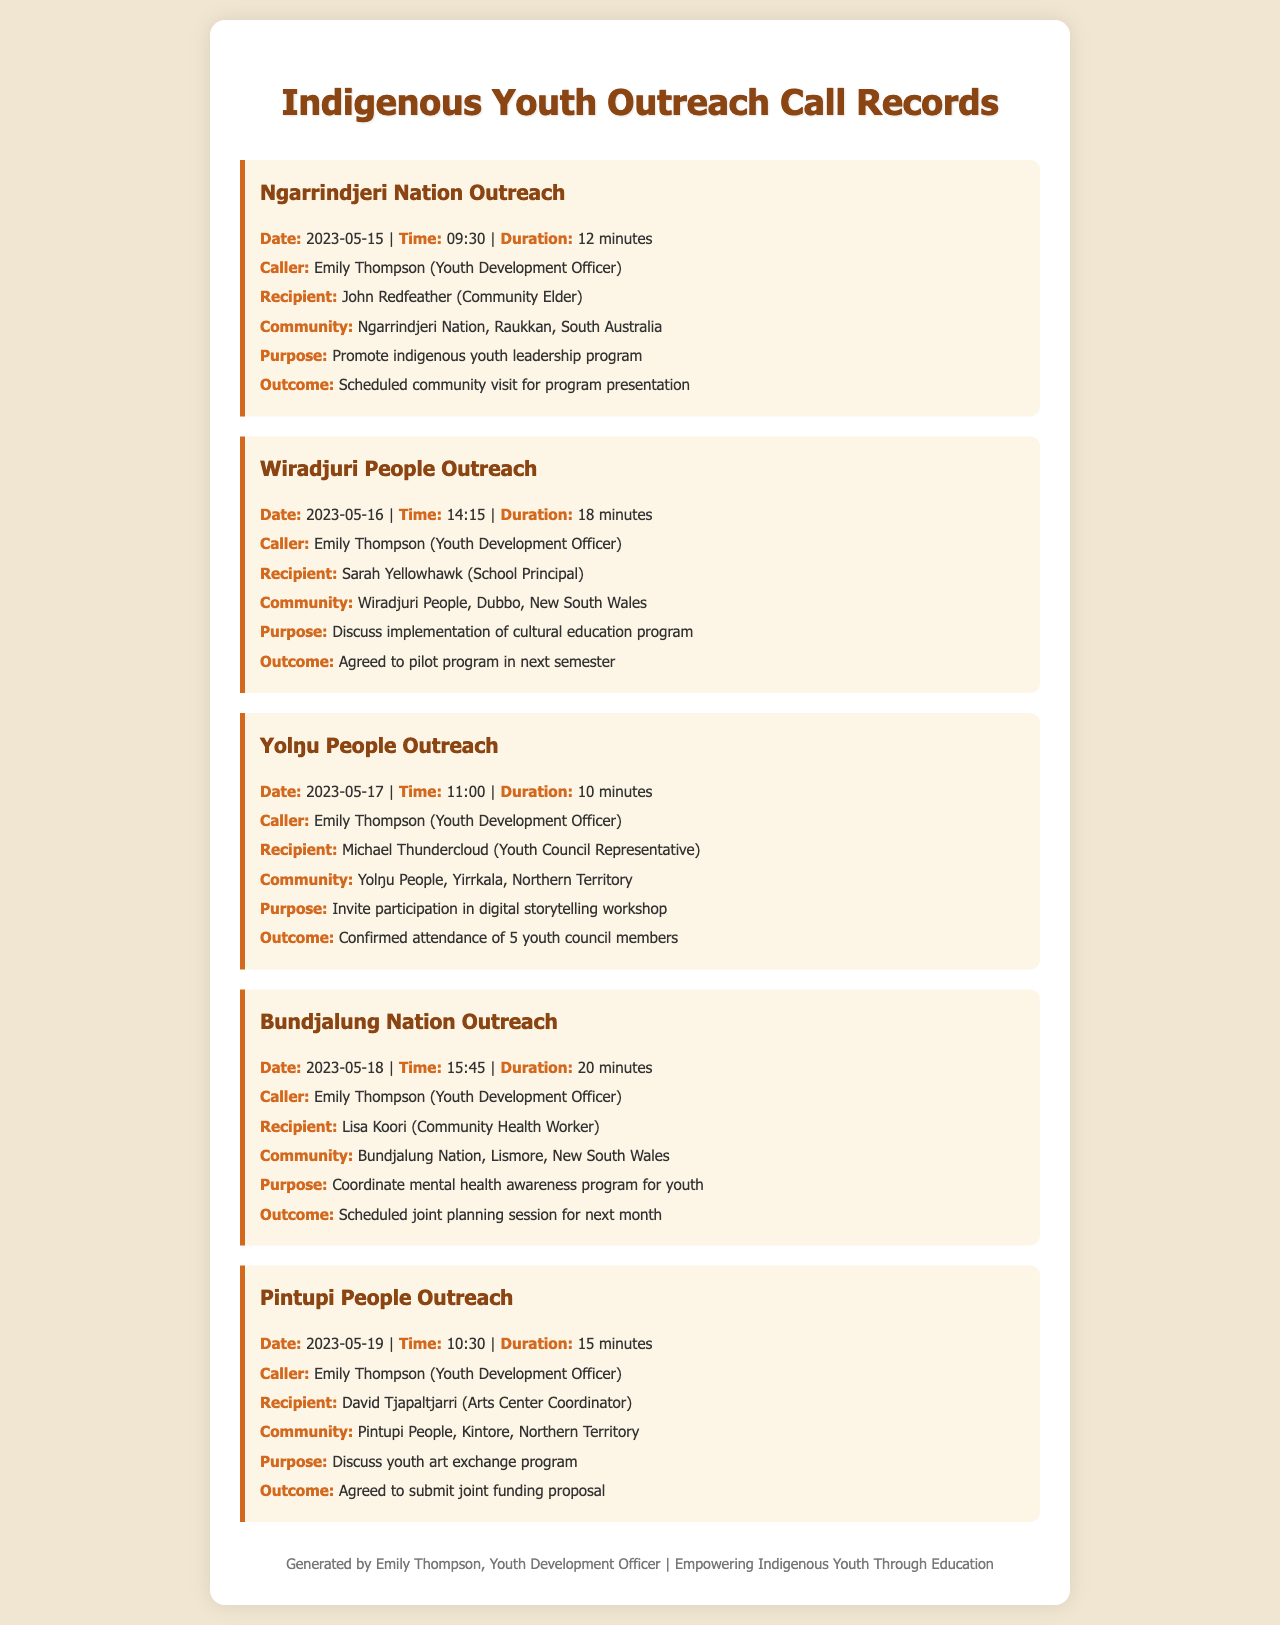what was the duration of the Ngarrindjeri Nation call? The duration is listed in the document as 12 minutes.
Answer: 12 minutes who was the caller for the Bundjalung Nation outreach? The caller is mentioned in the record as Emily Thompson (Youth Development Officer).
Answer: Emily Thompson what was the purpose of the Yolŋu People outreach? The document states that the purpose was to invite participation in a digital storytelling workshop.
Answer: Invite participation in digital storytelling workshop how many youth council members confirmed attendance for the Yolŋu People outreach? The outcome in the document specifies that 5 youth council members confirmed attendance.
Answer: 5 youth council members what date was the call made to the Wiradjuri People? The document indicates the call date was 2023-05-16.
Answer: 2023-05-16 what was the outcome of the Pintupi People outreach call? The outcome noted that they agreed to submit a joint funding proposal.
Answer: Agreed to submit joint funding proposal who was the recipient of the call for the Ngarrindjeri Nation outreach? The recipient is identified in the document as John Redfeather (Community Elder).
Answer: John Redfeather what type of program was discussed during the call with the Wiradjuri People? The purpose mentioned in the document was to discuss the implementation of a cultural education program.
Answer: Implementation of cultural education program how long was the call made to the Bundjalung Nation? The document shows that the call duration was 20 minutes.
Answer: 20 minutes 